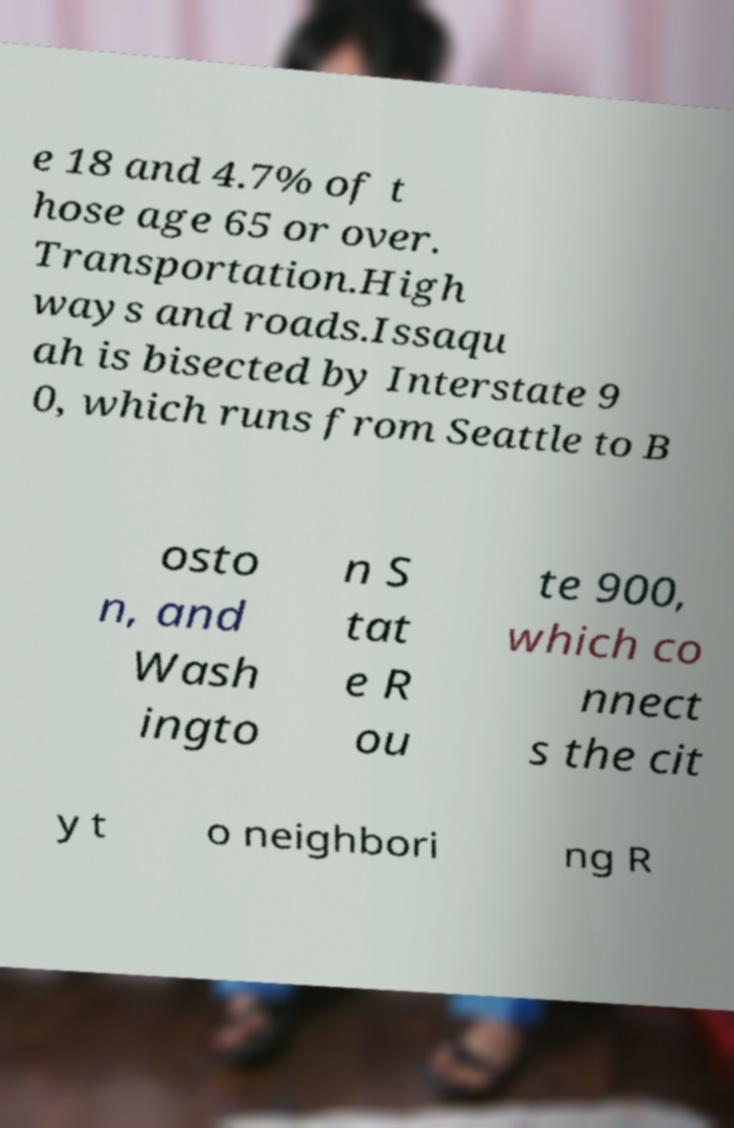There's text embedded in this image that I need extracted. Can you transcribe it verbatim? e 18 and 4.7% of t hose age 65 or over. Transportation.High ways and roads.Issaqu ah is bisected by Interstate 9 0, which runs from Seattle to B osto n, and Wash ingto n S tat e R ou te 900, which co nnect s the cit y t o neighbori ng R 